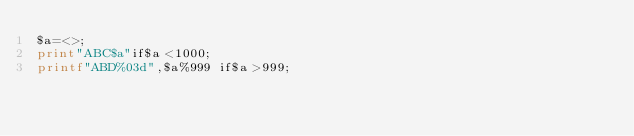Convert code to text. <code><loc_0><loc_0><loc_500><loc_500><_Perl_>$a=<>;
print"ABC$a"if$a<1000;
printf"ABD%03d",$a%999 if$a>999;</code> 